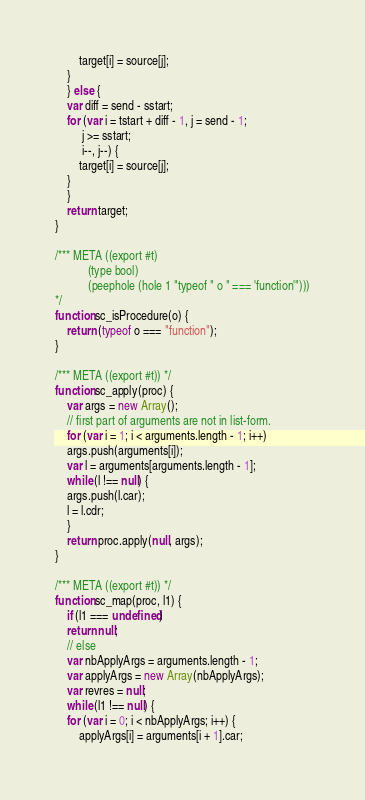Convert code to text. <code><loc_0><loc_0><loc_500><loc_500><_JavaScript_>	    target[i] = source[j];
	}
    } else {
	var diff = send - sstart;
	for (var i = tstart + diff - 1, j = send - 1;
	     j >= sstart;
	     i--, j--) {
	    target[i] = source[j];
	}
    }
    return target;
}

/*** META ((export #t)
           (type bool)
           (peephole (hole 1 "typeof " o " === 'function'")))
*/
function sc_isProcedure(o) {
    return (typeof o === "function");
}

/*** META ((export #t)) */
function sc_apply(proc) {
    var args = new Array();
    // first part of arguments are not in list-form.
    for (var i = 1; i < arguments.length - 1; i++)
	args.push(arguments[i]);
    var l = arguments[arguments.length - 1];
    while (l !== null) {
	args.push(l.car);
	l = l.cdr;
    }
    return proc.apply(null, args);
}

/*** META ((export #t)) */
function sc_map(proc, l1) {
    if (l1 === undefined)
	return null;
    // else
    var nbApplyArgs = arguments.length - 1;
    var applyArgs = new Array(nbApplyArgs);
    var revres = null;
    while (l1 !== null) {
	for (var i = 0; i < nbApplyArgs; i++) {
	    applyArgs[i] = arguments[i + 1].car;</code> 